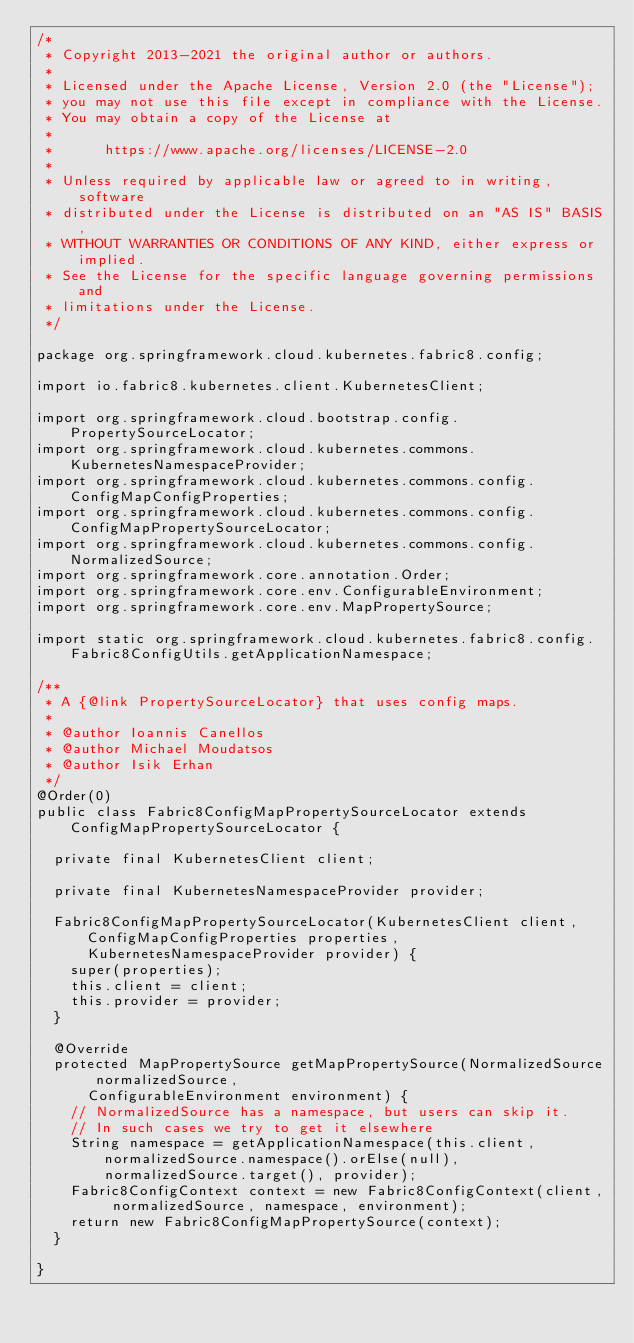<code> <loc_0><loc_0><loc_500><loc_500><_Java_>/*
 * Copyright 2013-2021 the original author or authors.
 *
 * Licensed under the Apache License, Version 2.0 (the "License");
 * you may not use this file except in compliance with the License.
 * You may obtain a copy of the License at
 *
 *      https://www.apache.org/licenses/LICENSE-2.0
 *
 * Unless required by applicable law or agreed to in writing, software
 * distributed under the License is distributed on an "AS IS" BASIS,
 * WITHOUT WARRANTIES OR CONDITIONS OF ANY KIND, either express or implied.
 * See the License for the specific language governing permissions and
 * limitations under the License.
 */

package org.springframework.cloud.kubernetes.fabric8.config;

import io.fabric8.kubernetes.client.KubernetesClient;

import org.springframework.cloud.bootstrap.config.PropertySourceLocator;
import org.springframework.cloud.kubernetes.commons.KubernetesNamespaceProvider;
import org.springframework.cloud.kubernetes.commons.config.ConfigMapConfigProperties;
import org.springframework.cloud.kubernetes.commons.config.ConfigMapPropertySourceLocator;
import org.springframework.cloud.kubernetes.commons.config.NormalizedSource;
import org.springframework.core.annotation.Order;
import org.springframework.core.env.ConfigurableEnvironment;
import org.springframework.core.env.MapPropertySource;

import static org.springframework.cloud.kubernetes.fabric8.config.Fabric8ConfigUtils.getApplicationNamespace;

/**
 * A {@link PropertySourceLocator} that uses config maps.
 *
 * @author Ioannis Canellos
 * @author Michael Moudatsos
 * @author Isik Erhan
 */
@Order(0)
public class Fabric8ConfigMapPropertySourceLocator extends ConfigMapPropertySourceLocator {

	private final KubernetesClient client;

	private final KubernetesNamespaceProvider provider;

	Fabric8ConfigMapPropertySourceLocator(KubernetesClient client, ConfigMapConfigProperties properties,
			KubernetesNamespaceProvider provider) {
		super(properties);
		this.client = client;
		this.provider = provider;
	}

	@Override
	protected MapPropertySource getMapPropertySource(NormalizedSource normalizedSource,
			ConfigurableEnvironment environment) {
		// NormalizedSource has a namespace, but users can skip it.
		// In such cases we try to get it elsewhere
		String namespace = getApplicationNamespace(this.client, normalizedSource.namespace().orElse(null),
				normalizedSource.target(), provider);
		Fabric8ConfigContext context = new Fabric8ConfigContext(client, normalizedSource, namespace, environment);
		return new Fabric8ConfigMapPropertySource(context);
	}

}
</code> 